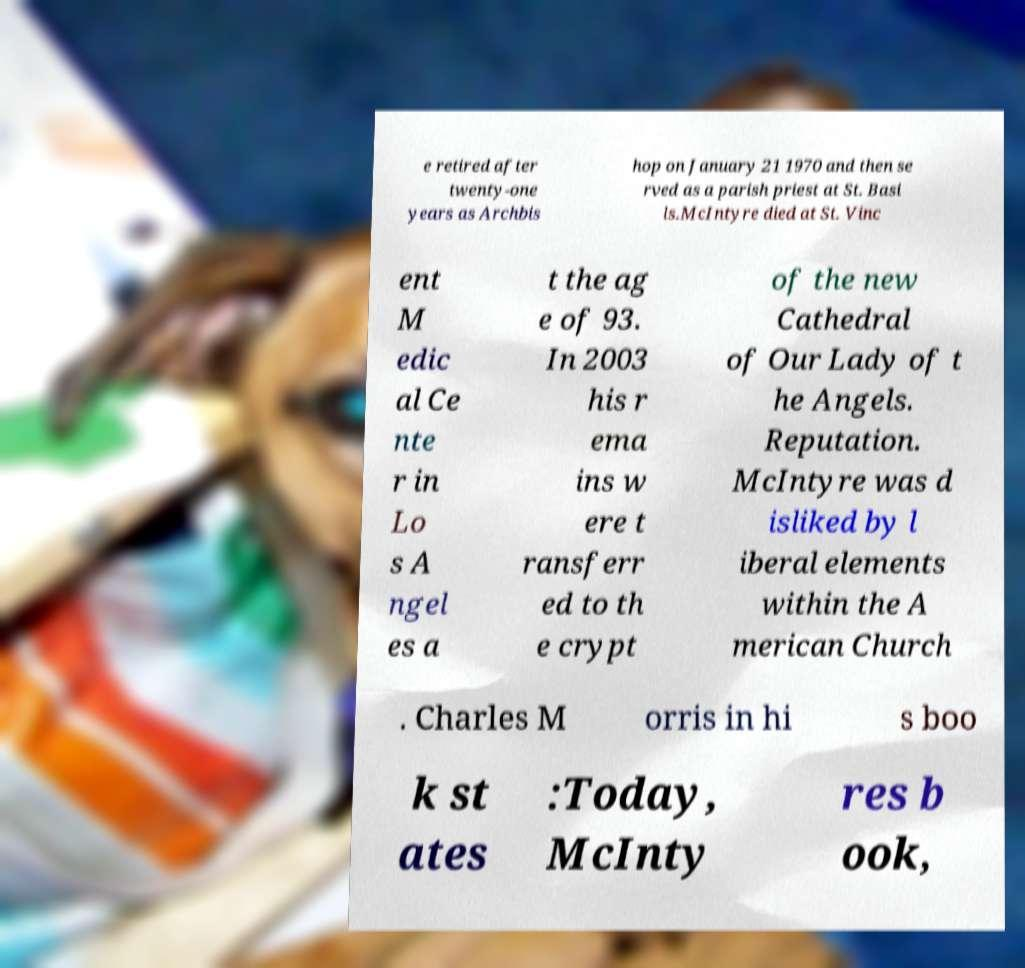I need the written content from this picture converted into text. Can you do that? e retired after twenty-one years as Archbis hop on January 21 1970 and then se rved as a parish priest at St. Basi ls.McIntyre died at St. Vinc ent M edic al Ce nte r in Lo s A ngel es a t the ag e of 93. In 2003 his r ema ins w ere t ransferr ed to th e crypt of the new Cathedral of Our Lady of t he Angels. Reputation. McIntyre was d isliked by l iberal elements within the A merican Church . Charles M orris in hi s boo k st ates :Today, McInty res b ook, 